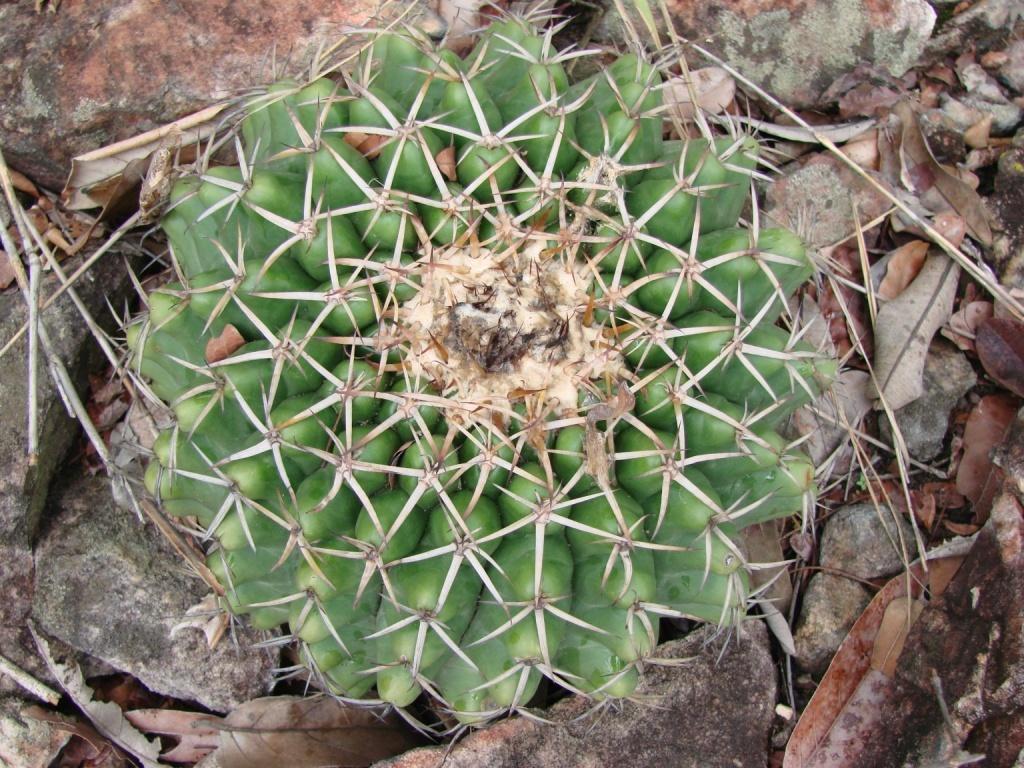How would you summarize this image in a sentence or two? In the center of the image we can see a hedgehog cactus. In the background of the image we can see the dry leaves and stones. 